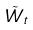Convert formula to latex. <formula><loc_0><loc_0><loc_500><loc_500>\tilde { W } _ { t }</formula> 